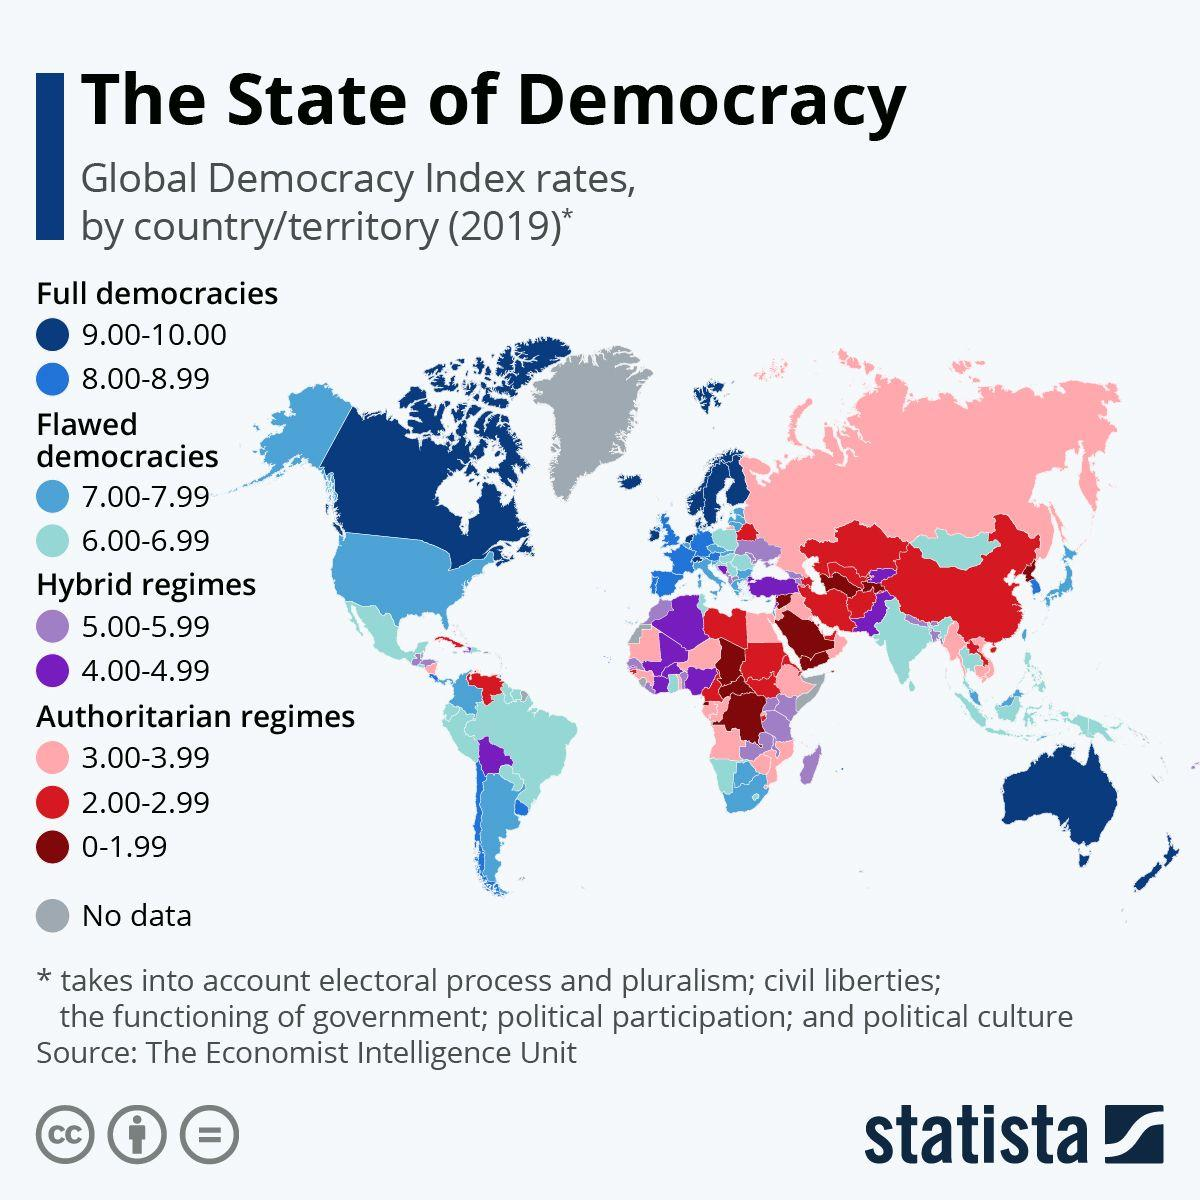Identify some key points in this picture. The red color in the charts indicates the presence of authoritarian regimes. The index rate of India falls within the range of 6.00 to 6.99. Somalia or Tanzania is not known to have data. The index rate of the hybrid regime in South America is between 4.00 and 4.99. India is a flawed democracy, characterized by ongoing challenges to its democratic institutions and processes. 